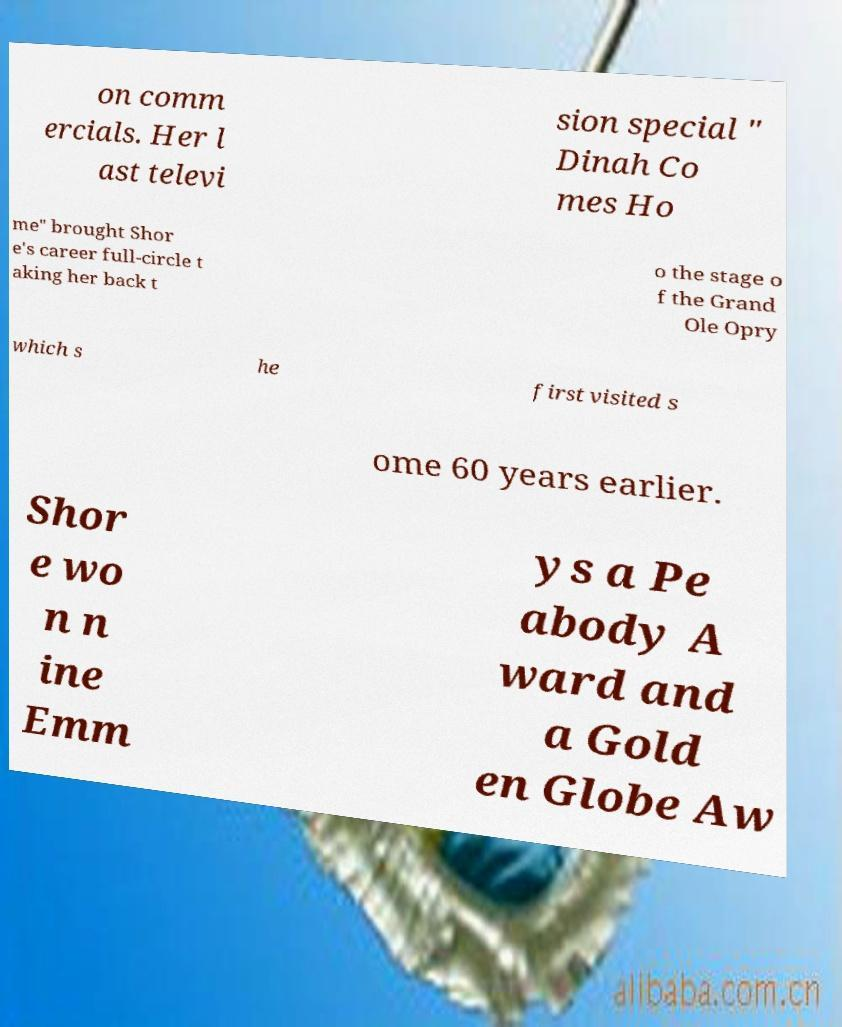Can you read and provide the text displayed in the image?This photo seems to have some interesting text. Can you extract and type it out for me? on comm ercials. Her l ast televi sion special " Dinah Co mes Ho me" brought Shor e's career full-circle t aking her back t o the stage o f the Grand Ole Opry which s he first visited s ome 60 years earlier. Shor e wo n n ine Emm ys a Pe abody A ward and a Gold en Globe Aw 